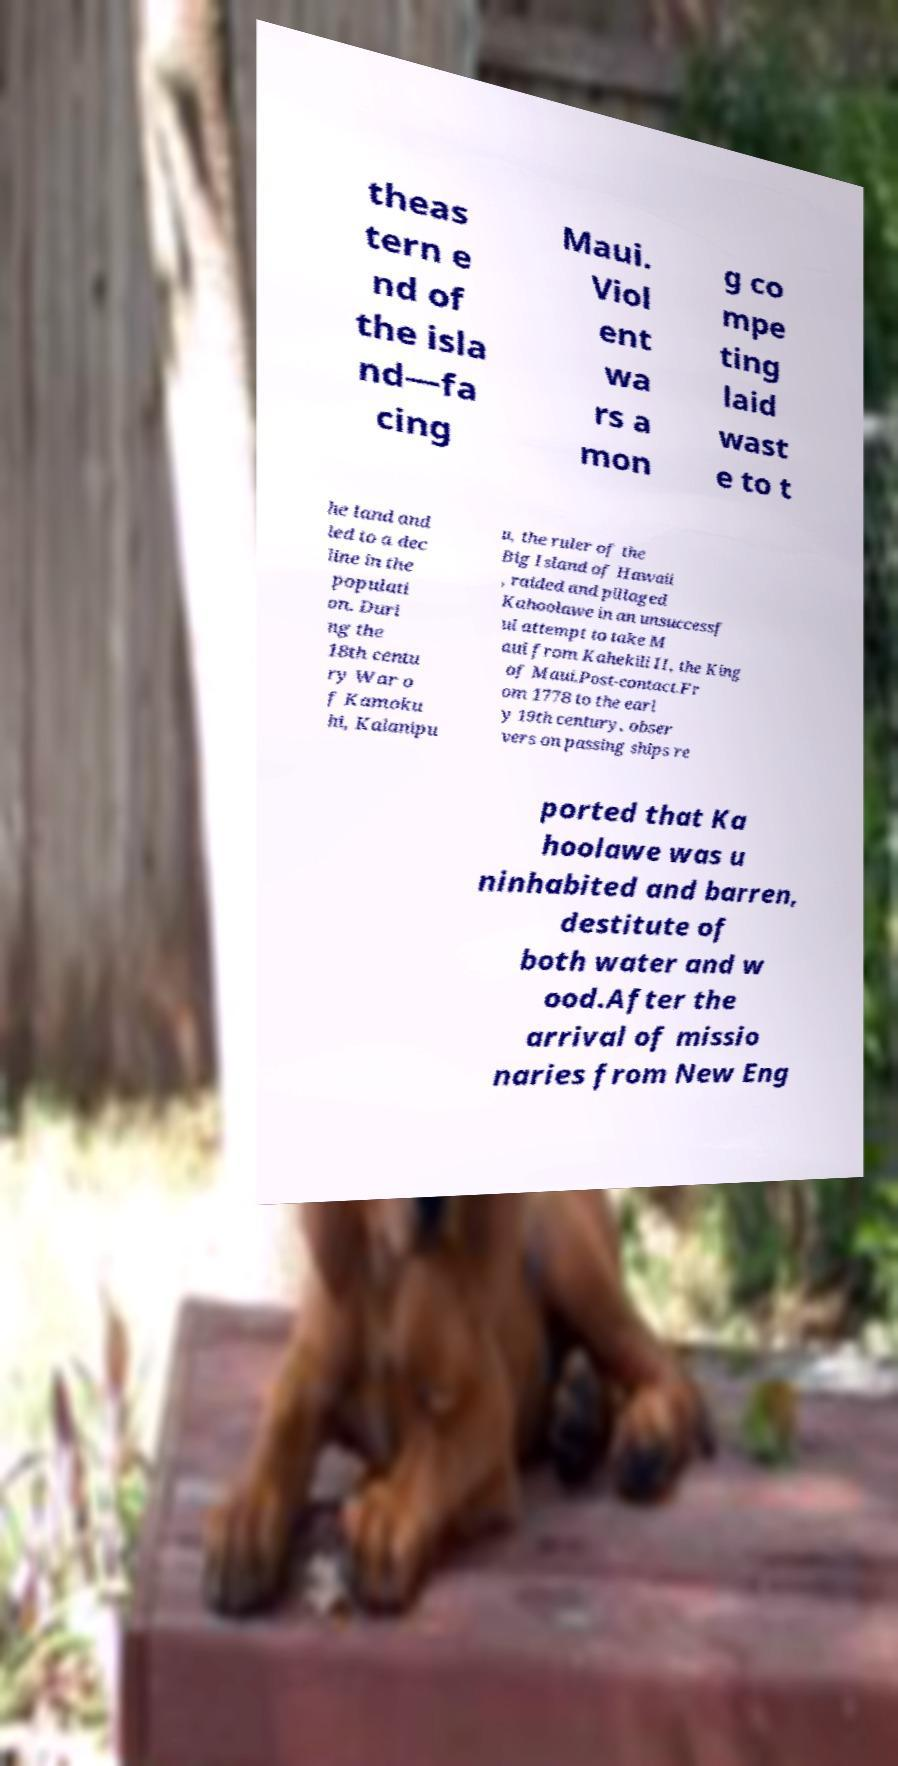For documentation purposes, I need the text within this image transcribed. Could you provide that? theas tern e nd of the isla nd—fa cing Maui. Viol ent wa rs a mon g co mpe ting laid wast e to t he land and led to a dec line in the populati on. Duri ng the 18th centu ry War o f Kamoku hi, Kalanipu u, the ruler of the Big Island of Hawaii , raided and pillaged Kahoolawe in an unsuccessf ul attempt to take M aui from Kahekili II, the King of Maui.Post-contact.Fr om 1778 to the earl y 19th century, obser vers on passing ships re ported that Ka hoolawe was u ninhabited and barren, destitute of both water and w ood.After the arrival of missio naries from New Eng 